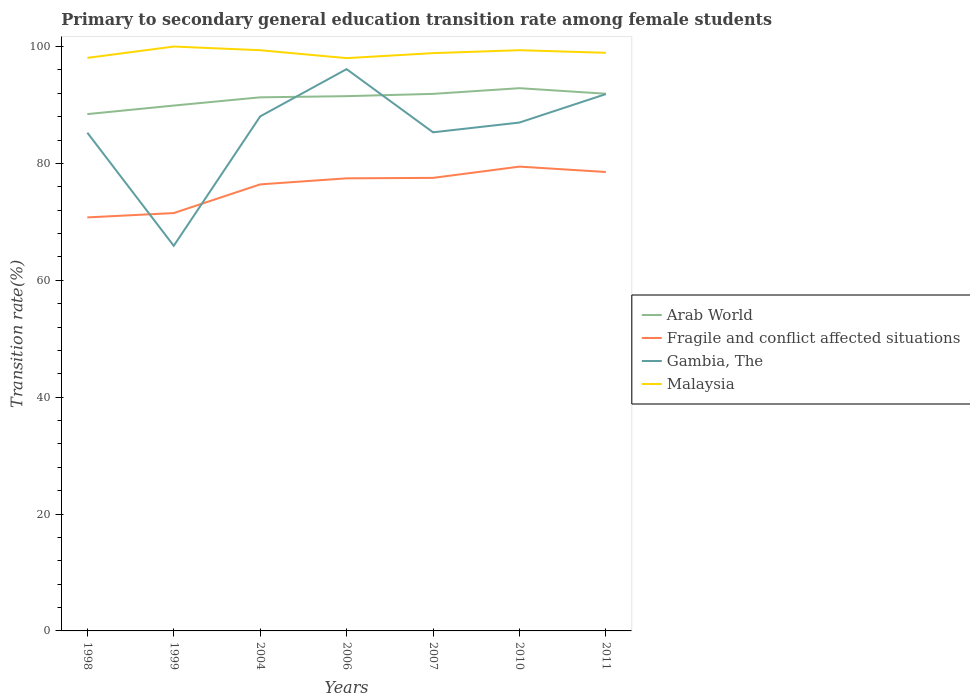How many different coloured lines are there?
Offer a very short reply. 4. Does the line corresponding to Fragile and conflict affected situations intersect with the line corresponding to Malaysia?
Your answer should be compact. No. Is the number of lines equal to the number of legend labels?
Ensure brevity in your answer.  Yes. Across all years, what is the maximum transition rate in Fragile and conflict affected situations?
Offer a terse response. 70.76. In which year was the transition rate in Malaysia maximum?
Make the answer very short. 2006. What is the total transition rate in Arab World in the graph?
Your answer should be compact. -3.07. What is the difference between the highest and the second highest transition rate in Gambia, The?
Keep it short and to the point. 30.23. Is the transition rate in Arab World strictly greater than the transition rate in Malaysia over the years?
Your answer should be very brief. Yes. How many years are there in the graph?
Ensure brevity in your answer.  7. What is the difference between two consecutive major ticks on the Y-axis?
Keep it short and to the point. 20. Are the values on the major ticks of Y-axis written in scientific E-notation?
Your response must be concise. No. Does the graph contain any zero values?
Provide a short and direct response. No. Where does the legend appear in the graph?
Keep it short and to the point. Center right. How are the legend labels stacked?
Keep it short and to the point. Vertical. What is the title of the graph?
Provide a short and direct response. Primary to secondary general education transition rate among female students. What is the label or title of the X-axis?
Offer a terse response. Years. What is the label or title of the Y-axis?
Provide a short and direct response. Transition rate(%). What is the Transition rate(%) in Arab World in 1998?
Ensure brevity in your answer.  88.44. What is the Transition rate(%) of Fragile and conflict affected situations in 1998?
Your answer should be very brief. 70.76. What is the Transition rate(%) of Gambia, The in 1998?
Your answer should be very brief. 85.26. What is the Transition rate(%) in Malaysia in 1998?
Your answer should be compact. 98.06. What is the Transition rate(%) in Arab World in 1999?
Your answer should be compact. 89.9. What is the Transition rate(%) of Fragile and conflict affected situations in 1999?
Offer a very short reply. 71.5. What is the Transition rate(%) of Gambia, The in 1999?
Provide a succinct answer. 65.9. What is the Transition rate(%) of Malaysia in 1999?
Ensure brevity in your answer.  100. What is the Transition rate(%) of Arab World in 2004?
Keep it short and to the point. 91.31. What is the Transition rate(%) of Fragile and conflict affected situations in 2004?
Keep it short and to the point. 76.41. What is the Transition rate(%) of Gambia, The in 2004?
Your response must be concise. 88.05. What is the Transition rate(%) of Malaysia in 2004?
Your response must be concise. 99.37. What is the Transition rate(%) in Arab World in 2006?
Your answer should be compact. 91.51. What is the Transition rate(%) in Fragile and conflict affected situations in 2006?
Your response must be concise. 77.45. What is the Transition rate(%) of Gambia, The in 2006?
Give a very brief answer. 96.13. What is the Transition rate(%) in Malaysia in 2006?
Keep it short and to the point. 98.02. What is the Transition rate(%) of Arab World in 2007?
Offer a terse response. 91.9. What is the Transition rate(%) in Fragile and conflict affected situations in 2007?
Keep it short and to the point. 77.52. What is the Transition rate(%) in Gambia, The in 2007?
Give a very brief answer. 85.32. What is the Transition rate(%) of Malaysia in 2007?
Your response must be concise. 98.87. What is the Transition rate(%) of Arab World in 2010?
Provide a short and direct response. 92.87. What is the Transition rate(%) in Fragile and conflict affected situations in 2010?
Provide a short and direct response. 79.45. What is the Transition rate(%) in Gambia, The in 2010?
Make the answer very short. 86.99. What is the Transition rate(%) of Malaysia in 2010?
Ensure brevity in your answer.  99.37. What is the Transition rate(%) of Arab World in 2011?
Ensure brevity in your answer.  91.92. What is the Transition rate(%) in Fragile and conflict affected situations in 2011?
Your answer should be very brief. 78.53. What is the Transition rate(%) in Gambia, The in 2011?
Your response must be concise. 91.86. What is the Transition rate(%) of Malaysia in 2011?
Provide a short and direct response. 98.93. Across all years, what is the maximum Transition rate(%) in Arab World?
Ensure brevity in your answer.  92.87. Across all years, what is the maximum Transition rate(%) of Fragile and conflict affected situations?
Provide a succinct answer. 79.45. Across all years, what is the maximum Transition rate(%) in Gambia, The?
Give a very brief answer. 96.13. Across all years, what is the minimum Transition rate(%) of Arab World?
Your answer should be compact. 88.44. Across all years, what is the minimum Transition rate(%) of Fragile and conflict affected situations?
Your answer should be very brief. 70.76. Across all years, what is the minimum Transition rate(%) of Gambia, The?
Keep it short and to the point. 65.9. Across all years, what is the minimum Transition rate(%) of Malaysia?
Your answer should be compact. 98.02. What is the total Transition rate(%) in Arab World in the graph?
Make the answer very short. 637.85. What is the total Transition rate(%) in Fragile and conflict affected situations in the graph?
Give a very brief answer. 531.63. What is the total Transition rate(%) of Gambia, The in the graph?
Keep it short and to the point. 599.52. What is the total Transition rate(%) of Malaysia in the graph?
Offer a very short reply. 692.62. What is the difference between the Transition rate(%) in Arab World in 1998 and that in 1999?
Provide a short and direct response. -1.46. What is the difference between the Transition rate(%) in Fragile and conflict affected situations in 1998 and that in 1999?
Make the answer very short. -0.74. What is the difference between the Transition rate(%) of Gambia, The in 1998 and that in 1999?
Provide a succinct answer. 19.36. What is the difference between the Transition rate(%) in Malaysia in 1998 and that in 1999?
Make the answer very short. -1.94. What is the difference between the Transition rate(%) of Arab World in 1998 and that in 2004?
Make the answer very short. -2.87. What is the difference between the Transition rate(%) in Fragile and conflict affected situations in 1998 and that in 2004?
Provide a succinct answer. -5.65. What is the difference between the Transition rate(%) of Gambia, The in 1998 and that in 2004?
Ensure brevity in your answer.  -2.79. What is the difference between the Transition rate(%) in Malaysia in 1998 and that in 2004?
Give a very brief answer. -1.31. What is the difference between the Transition rate(%) in Arab World in 1998 and that in 2006?
Your response must be concise. -3.07. What is the difference between the Transition rate(%) in Fragile and conflict affected situations in 1998 and that in 2006?
Make the answer very short. -6.69. What is the difference between the Transition rate(%) of Gambia, The in 1998 and that in 2006?
Offer a terse response. -10.87. What is the difference between the Transition rate(%) of Malaysia in 1998 and that in 2006?
Your answer should be very brief. 0.04. What is the difference between the Transition rate(%) in Arab World in 1998 and that in 2007?
Give a very brief answer. -3.46. What is the difference between the Transition rate(%) in Fragile and conflict affected situations in 1998 and that in 2007?
Provide a short and direct response. -6.76. What is the difference between the Transition rate(%) in Gambia, The in 1998 and that in 2007?
Provide a short and direct response. -0.06. What is the difference between the Transition rate(%) of Malaysia in 1998 and that in 2007?
Make the answer very short. -0.81. What is the difference between the Transition rate(%) in Arab World in 1998 and that in 2010?
Your answer should be very brief. -4.44. What is the difference between the Transition rate(%) of Fragile and conflict affected situations in 1998 and that in 2010?
Provide a succinct answer. -8.69. What is the difference between the Transition rate(%) of Gambia, The in 1998 and that in 2010?
Provide a succinct answer. -1.73. What is the difference between the Transition rate(%) in Malaysia in 1998 and that in 2010?
Keep it short and to the point. -1.32. What is the difference between the Transition rate(%) of Arab World in 1998 and that in 2011?
Your response must be concise. -3.49. What is the difference between the Transition rate(%) of Fragile and conflict affected situations in 1998 and that in 2011?
Make the answer very short. -7.77. What is the difference between the Transition rate(%) of Gambia, The in 1998 and that in 2011?
Your response must be concise. -6.6. What is the difference between the Transition rate(%) in Malaysia in 1998 and that in 2011?
Your answer should be very brief. -0.87. What is the difference between the Transition rate(%) of Arab World in 1999 and that in 2004?
Offer a very short reply. -1.41. What is the difference between the Transition rate(%) in Fragile and conflict affected situations in 1999 and that in 2004?
Your answer should be very brief. -4.91. What is the difference between the Transition rate(%) in Gambia, The in 1999 and that in 2004?
Provide a succinct answer. -22.15. What is the difference between the Transition rate(%) of Malaysia in 1999 and that in 2004?
Give a very brief answer. 0.63. What is the difference between the Transition rate(%) of Arab World in 1999 and that in 2006?
Give a very brief answer. -1.61. What is the difference between the Transition rate(%) in Fragile and conflict affected situations in 1999 and that in 2006?
Your response must be concise. -5.95. What is the difference between the Transition rate(%) of Gambia, The in 1999 and that in 2006?
Your answer should be compact. -30.23. What is the difference between the Transition rate(%) in Malaysia in 1999 and that in 2006?
Your answer should be very brief. 1.98. What is the difference between the Transition rate(%) in Arab World in 1999 and that in 2007?
Provide a short and direct response. -2. What is the difference between the Transition rate(%) of Fragile and conflict affected situations in 1999 and that in 2007?
Offer a terse response. -6.02. What is the difference between the Transition rate(%) of Gambia, The in 1999 and that in 2007?
Make the answer very short. -19.42. What is the difference between the Transition rate(%) in Malaysia in 1999 and that in 2007?
Make the answer very short. 1.13. What is the difference between the Transition rate(%) of Arab World in 1999 and that in 2010?
Offer a very short reply. -2.97. What is the difference between the Transition rate(%) of Fragile and conflict affected situations in 1999 and that in 2010?
Offer a terse response. -7.95. What is the difference between the Transition rate(%) in Gambia, The in 1999 and that in 2010?
Offer a terse response. -21.09. What is the difference between the Transition rate(%) in Malaysia in 1999 and that in 2010?
Offer a terse response. 0.63. What is the difference between the Transition rate(%) in Arab World in 1999 and that in 2011?
Provide a succinct answer. -2.02. What is the difference between the Transition rate(%) of Fragile and conflict affected situations in 1999 and that in 2011?
Offer a terse response. -7.03. What is the difference between the Transition rate(%) of Gambia, The in 1999 and that in 2011?
Your answer should be compact. -25.96. What is the difference between the Transition rate(%) of Malaysia in 1999 and that in 2011?
Give a very brief answer. 1.07. What is the difference between the Transition rate(%) of Arab World in 2004 and that in 2006?
Your response must be concise. -0.2. What is the difference between the Transition rate(%) in Fragile and conflict affected situations in 2004 and that in 2006?
Keep it short and to the point. -1.04. What is the difference between the Transition rate(%) of Gambia, The in 2004 and that in 2006?
Your response must be concise. -8.09. What is the difference between the Transition rate(%) in Malaysia in 2004 and that in 2006?
Your response must be concise. 1.35. What is the difference between the Transition rate(%) in Arab World in 2004 and that in 2007?
Keep it short and to the point. -0.59. What is the difference between the Transition rate(%) in Fragile and conflict affected situations in 2004 and that in 2007?
Your response must be concise. -1.11. What is the difference between the Transition rate(%) in Gambia, The in 2004 and that in 2007?
Your answer should be compact. 2.72. What is the difference between the Transition rate(%) of Malaysia in 2004 and that in 2007?
Make the answer very short. 0.5. What is the difference between the Transition rate(%) of Arab World in 2004 and that in 2010?
Offer a terse response. -1.56. What is the difference between the Transition rate(%) of Fragile and conflict affected situations in 2004 and that in 2010?
Provide a succinct answer. -3.04. What is the difference between the Transition rate(%) of Gambia, The in 2004 and that in 2010?
Your answer should be very brief. 1.05. What is the difference between the Transition rate(%) of Malaysia in 2004 and that in 2010?
Provide a succinct answer. -0. What is the difference between the Transition rate(%) of Arab World in 2004 and that in 2011?
Ensure brevity in your answer.  -0.61. What is the difference between the Transition rate(%) of Fragile and conflict affected situations in 2004 and that in 2011?
Keep it short and to the point. -2.12. What is the difference between the Transition rate(%) of Gambia, The in 2004 and that in 2011?
Offer a terse response. -3.82. What is the difference between the Transition rate(%) of Malaysia in 2004 and that in 2011?
Provide a short and direct response. 0.44. What is the difference between the Transition rate(%) of Arab World in 2006 and that in 2007?
Offer a very short reply. -0.39. What is the difference between the Transition rate(%) of Fragile and conflict affected situations in 2006 and that in 2007?
Ensure brevity in your answer.  -0.08. What is the difference between the Transition rate(%) of Gambia, The in 2006 and that in 2007?
Give a very brief answer. 10.81. What is the difference between the Transition rate(%) in Malaysia in 2006 and that in 2007?
Provide a short and direct response. -0.86. What is the difference between the Transition rate(%) in Arab World in 2006 and that in 2010?
Provide a short and direct response. -1.36. What is the difference between the Transition rate(%) in Fragile and conflict affected situations in 2006 and that in 2010?
Provide a succinct answer. -2. What is the difference between the Transition rate(%) in Gambia, The in 2006 and that in 2010?
Your answer should be very brief. 9.14. What is the difference between the Transition rate(%) in Malaysia in 2006 and that in 2010?
Keep it short and to the point. -1.36. What is the difference between the Transition rate(%) of Arab World in 2006 and that in 2011?
Your answer should be very brief. -0.41. What is the difference between the Transition rate(%) in Fragile and conflict affected situations in 2006 and that in 2011?
Offer a terse response. -1.08. What is the difference between the Transition rate(%) in Gambia, The in 2006 and that in 2011?
Offer a very short reply. 4.27. What is the difference between the Transition rate(%) in Malaysia in 2006 and that in 2011?
Provide a succinct answer. -0.91. What is the difference between the Transition rate(%) of Arab World in 2007 and that in 2010?
Your answer should be compact. -0.97. What is the difference between the Transition rate(%) of Fragile and conflict affected situations in 2007 and that in 2010?
Provide a succinct answer. -1.93. What is the difference between the Transition rate(%) of Gambia, The in 2007 and that in 2010?
Ensure brevity in your answer.  -1.67. What is the difference between the Transition rate(%) in Malaysia in 2007 and that in 2010?
Keep it short and to the point. -0.5. What is the difference between the Transition rate(%) in Arab World in 2007 and that in 2011?
Provide a succinct answer. -0.02. What is the difference between the Transition rate(%) of Fragile and conflict affected situations in 2007 and that in 2011?
Give a very brief answer. -1.01. What is the difference between the Transition rate(%) in Gambia, The in 2007 and that in 2011?
Ensure brevity in your answer.  -6.54. What is the difference between the Transition rate(%) of Malaysia in 2007 and that in 2011?
Make the answer very short. -0.06. What is the difference between the Transition rate(%) in Arab World in 2010 and that in 2011?
Ensure brevity in your answer.  0.95. What is the difference between the Transition rate(%) of Fragile and conflict affected situations in 2010 and that in 2011?
Your response must be concise. 0.92. What is the difference between the Transition rate(%) of Gambia, The in 2010 and that in 2011?
Provide a short and direct response. -4.87. What is the difference between the Transition rate(%) in Malaysia in 2010 and that in 2011?
Offer a terse response. 0.45. What is the difference between the Transition rate(%) of Arab World in 1998 and the Transition rate(%) of Fragile and conflict affected situations in 1999?
Offer a terse response. 16.94. What is the difference between the Transition rate(%) in Arab World in 1998 and the Transition rate(%) in Gambia, The in 1999?
Offer a terse response. 22.54. What is the difference between the Transition rate(%) in Arab World in 1998 and the Transition rate(%) in Malaysia in 1999?
Provide a succinct answer. -11.56. What is the difference between the Transition rate(%) in Fragile and conflict affected situations in 1998 and the Transition rate(%) in Gambia, The in 1999?
Your response must be concise. 4.86. What is the difference between the Transition rate(%) in Fragile and conflict affected situations in 1998 and the Transition rate(%) in Malaysia in 1999?
Make the answer very short. -29.24. What is the difference between the Transition rate(%) in Gambia, The in 1998 and the Transition rate(%) in Malaysia in 1999?
Make the answer very short. -14.74. What is the difference between the Transition rate(%) in Arab World in 1998 and the Transition rate(%) in Fragile and conflict affected situations in 2004?
Provide a succinct answer. 12.02. What is the difference between the Transition rate(%) in Arab World in 1998 and the Transition rate(%) in Gambia, The in 2004?
Your response must be concise. 0.39. What is the difference between the Transition rate(%) of Arab World in 1998 and the Transition rate(%) of Malaysia in 2004?
Provide a succinct answer. -10.93. What is the difference between the Transition rate(%) in Fragile and conflict affected situations in 1998 and the Transition rate(%) in Gambia, The in 2004?
Your response must be concise. -17.29. What is the difference between the Transition rate(%) of Fragile and conflict affected situations in 1998 and the Transition rate(%) of Malaysia in 2004?
Give a very brief answer. -28.61. What is the difference between the Transition rate(%) in Gambia, The in 1998 and the Transition rate(%) in Malaysia in 2004?
Your response must be concise. -14.11. What is the difference between the Transition rate(%) in Arab World in 1998 and the Transition rate(%) in Fragile and conflict affected situations in 2006?
Your answer should be very brief. 10.99. What is the difference between the Transition rate(%) in Arab World in 1998 and the Transition rate(%) in Gambia, The in 2006?
Your answer should be compact. -7.7. What is the difference between the Transition rate(%) of Arab World in 1998 and the Transition rate(%) of Malaysia in 2006?
Make the answer very short. -9.58. What is the difference between the Transition rate(%) in Fragile and conflict affected situations in 1998 and the Transition rate(%) in Gambia, The in 2006?
Your response must be concise. -25.37. What is the difference between the Transition rate(%) of Fragile and conflict affected situations in 1998 and the Transition rate(%) of Malaysia in 2006?
Your response must be concise. -27.25. What is the difference between the Transition rate(%) of Gambia, The in 1998 and the Transition rate(%) of Malaysia in 2006?
Make the answer very short. -12.75. What is the difference between the Transition rate(%) in Arab World in 1998 and the Transition rate(%) in Fragile and conflict affected situations in 2007?
Provide a succinct answer. 10.91. What is the difference between the Transition rate(%) in Arab World in 1998 and the Transition rate(%) in Gambia, The in 2007?
Provide a succinct answer. 3.11. What is the difference between the Transition rate(%) of Arab World in 1998 and the Transition rate(%) of Malaysia in 2007?
Offer a very short reply. -10.44. What is the difference between the Transition rate(%) in Fragile and conflict affected situations in 1998 and the Transition rate(%) in Gambia, The in 2007?
Offer a very short reply. -14.56. What is the difference between the Transition rate(%) in Fragile and conflict affected situations in 1998 and the Transition rate(%) in Malaysia in 2007?
Give a very brief answer. -28.11. What is the difference between the Transition rate(%) in Gambia, The in 1998 and the Transition rate(%) in Malaysia in 2007?
Your answer should be very brief. -13.61. What is the difference between the Transition rate(%) in Arab World in 1998 and the Transition rate(%) in Fragile and conflict affected situations in 2010?
Provide a succinct answer. 8.98. What is the difference between the Transition rate(%) of Arab World in 1998 and the Transition rate(%) of Gambia, The in 2010?
Provide a succinct answer. 1.44. What is the difference between the Transition rate(%) in Arab World in 1998 and the Transition rate(%) in Malaysia in 2010?
Offer a very short reply. -10.94. What is the difference between the Transition rate(%) of Fragile and conflict affected situations in 1998 and the Transition rate(%) of Gambia, The in 2010?
Offer a very short reply. -16.23. What is the difference between the Transition rate(%) in Fragile and conflict affected situations in 1998 and the Transition rate(%) in Malaysia in 2010?
Keep it short and to the point. -28.61. What is the difference between the Transition rate(%) in Gambia, The in 1998 and the Transition rate(%) in Malaysia in 2010?
Ensure brevity in your answer.  -14.11. What is the difference between the Transition rate(%) in Arab World in 1998 and the Transition rate(%) in Fragile and conflict affected situations in 2011?
Your response must be concise. 9.91. What is the difference between the Transition rate(%) of Arab World in 1998 and the Transition rate(%) of Gambia, The in 2011?
Make the answer very short. -3.43. What is the difference between the Transition rate(%) in Arab World in 1998 and the Transition rate(%) in Malaysia in 2011?
Your response must be concise. -10.49. What is the difference between the Transition rate(%) in Fragile and conflict affected situations in 1998 and the Transition rate(%) in Gambia, The in 2011?
Keep it short and to the point. -21.1. What is the difference between the Transition rate(%) in Fragile and conflict affected situations in 1998 and the Transition rate(%) in Malaysia in 2011?
Provide a short and direct response. -28.17. What is the difference between the Transition rate(%) in Gambia, The in 1998 and the Transition rate(%) in Malaysia in 2011?
Make the answer very short. -13.67. What is the difference between the Transition rate(%) in Arab World in 1999 and the Transition rate(%) in Fragile and conflict affected situations in 2004?
Give a very brief answer. 13.49. What is the difference between the Transition rate(%) of Arab World in 1999 and the Transition rate(%) of Gambia, The in 2004?
Offer a terse response. 1.85. What is the difference between the Transition rate(%) of Arab World in 1999 and the Transition rate(%) of Malaysia in 2004?
Your answer should be compact. -9.47. What is the difference between the Transition rate(%) in Fragile and conflict affected situations in 1999 and the Transition rate(%) in Gambia, The in 2004?
Offer a terse response. -16.55. What is the difference between the Transition rate(%) of Fragile and conflict affected situations in 1999 and the Transition rate(%) of Malaysia in 2004?
Your answer should be compact. -27.87. What is the difference between the Transition rate(%) in Gambia, The in 1999 and the Transition rate(%) in Malaysia in 2004?
Make the answer very short. -33.47. What is the difference between the Transition rate(%) of Arab World in 1999 and the Transition rate(%) of Fragile and conflict affected situations in 2006?
Your response must be concise. 12.45. What is the difference between the Transition rate(%) in Arab World in 1999 and the Transition rate(%) in Gambia, The in 2006?
Give a very brief answer. -6.23. What is the difference between the Transition rate(%) of Arab World in 1999 and the Transition rate(%) of Malaysia in 2006?
Make the answer very short. -8.12. What is the difference between the Transition rate(%) of Fragile and conflict affected situations in 1999 and the Transition rate(%) of Gambia, The in 2006?
Give a very brief answer. -24.63. What is the difference between the Transition rate(%) of Fragile and conflict affected situations in 1999 and the Transition rate(%) of Malaysia in 2006?
Make the answer very short. -26.51. What is the difference between the Transition rate(%) in Gambia, The in 1999 and the Transition rate(%) in Malaysia in 2006?
Give a very brief answer. -32.11. What is the difference between the Transition rate(%) of Arab World in 1999 and the Transition rate(%) of Fragile and conflict affected situations in 2007?
Make the answer very short. 12.38. What is the difference between the Transition rate(%) in Arab World in 1999 and the Transition rate(%) in Gambia, The in 2007?
Give a very brief answer. 4.58. What is the difference between the Transition rate(%) of Arab World in 1999 and the Transition rate(%) of Malaysia in 2007?
Make the answer very short. -8.97. What is the difference between the Transition rate(%) in Fragile and conflict affected situations in 1999 and the Transition rate(%) in Gambia, The in 2007?
Give a very brief answer. -13.82. What is the difference between the Transition rate(%) in Fragile and conflict affected situations in 1999 and the Transition rate(%) in Malaysia in 2007?
Provide a short and direct response. -27.37. What is the difference between the Transition rate(%) in Gambia, The in 1999 and the Transition rate(%) in Malaysia in 2007?
Make the answer very short. -32.97. What is the difference between the Transition rate(%) of Arab World in 1999 and the Transition rate(%) of Fragile and conflict affected situations in 2010?
Make the answer very short. 10.45. What is the difference between the Transition rate(%) of Arab World in 1999 and the Transition rate(%) of Gambia, The in 2010?
Provide a short and direct response. 2.91. What is the difference between the Transition rate(%) of Arab World in 1999 and the Transition rate(%) of Malaysia in 2010?
Give a very brief answer. -9.47. What is the difference between the Transition rate(%) of Fragile and conflict affected situations in 1999 and the Transition rate(%) of Gambia, The in 2010?
Give a very brief answer. -15.49. What is the difference between the Transition rate(%) of Fragile and conflict affected situations in 1999 and the Transition rate(%) of Malaysia in 2010?
Provide a succinct answer. -27.87. What is the difference between the Transition rate(%) of Gambia, The in 1999 and the Transition rate(%) of Malaysia in 2010?
Your answer should be very brief. -33.47. What is the difference between the Transition rate(%) of Arab World in 1999 and the Transition rate(%) of Fragile and conflict affected situations in 2011?
Provide a succinct answer. 11.37. What is the difference between the Transition rate(%) of Arab World in 1999 and the Transition rate(%) of Gambia, The in 2011?
Your answer should be very brief. -1.96. What is the difference between the Transition rate(%) of Arab World in 1999 and the Transition rate(%) of Malaysia in 2011?
Offer a very short reply. -9.03. What is the difference between the Transition rate(%) in Fragile and conflict affected situations in 1999 and the Transition rate(%) in Gambia, The in 2011?
Your response must be concise. -20.36. What is the difference between the Transition rate(%) in Fragile and conflict affected situations in 1999 and the Transition rate(%) in Malaysia in 2011?
Your answer should be very brief. -27.43. What is the difference between the Transition rate(%) in Gambia, The in 1999 and the Transition rate(%) in Malaysia in 2011?
Keep it short and to the point. -33.03. What is the difference between the Transition rate(%) in Arab World in 2004 and the Transition rate(%) in Fragile and conflict affected situations in 2006?
Give a very brief answer. 13.86. What is the difference between the Transition rate(%) of Arab World in 2004 and the Transition rate(%) of Gambia, The in 2006?
Make the answer very short. -4.82. What is the difference between the Transition rate(%) of Arab World in 2004 and the Transition rate(%) of Malaysia in 2006?
Offer a very short reply. -6.71. What is the difference between the Transition rate(%) of Fragile and conflict affected situations in 2004 and the Transition rate(%) of Gambia, The in 2006?
Provide a succinct answer. -19.72. What is the difference between the Transition rate(%) in Fragile and conflict affected situations in 2004 and the Transition rate(%) in Malaysia in 2006?
Your answer should be very brief. -21.6. What is the difference between the Transition rate(%) in Gambia, The in 2004 and the Transition rate(%) in Malaysia in 2006?
Provide a short and direct response. -9.97. What is the difference between the Transition rate(%) in Arab World in 2004 and the Transition rate(%) in Fragile and conflict affected situations in 2007?
Keep it short and to the point. 13.79. What is the difference between the Transition rate(%) of Arab World in 2004 and the Transition rate(%) of Gambia, The in 2007?
Provide a short and direct response. 5.99. What is the difference between the Transition rate(%) of Arab World in 2004 and the Transition rate(%) of Malaysia in 2007?
Your answer should be compact. -7.56. What is the difference between the Transition rate(%) in Fragile and conflict affected situations in 2004 and the Transition rate(%) in Gambia, The in 2007?
Make the answer very short. -8.91. What is the difference between the Transition rate(%) of Fragile and conflict affected situations in 2004 and the Transition rate(%) of Malaysia in 2007?
Keep it short and to the point. -22.46. What is the difference between the Transition rate(%) in Gambia, The in 2004 and the Transition rate(%) in Malaysia in 2007?
Provide a succinct answer. -10.83. What is the difference between the Transition rate(%) in Arab World in 2004 and the Transition rate(%) in Fragile and conflict affected situations in 2010?
Your response must be concise. 11.86. What is the difference between the Transition rate(%) of Arab World in 2004 and the Transition rate(%) of Gambia, The in 2010?
Offer a very short reply. 4.32. What is the difference between the Transition rate(%) in Arab World in 2004 and the Transition rate(%) in Malaysia in 2010?
Offer a terse response. -8.06. What is the difference between the Transition rate(%) of Fragile and conflict affected situations in 2004 and the Transition rate(%) of Gambia, The in 2010?
Provide a succinct answer. -10.58. What is the difference between the Transition rate(%) in Fragile and conflict affected situations in 2004 and the Transition rate(%) in Malaysia in 2010?
Offer a very short reply. -22.96. What is the difference between the Transition rate(%) of Gambia, The in 2004 and the Transition rate(%) of Malaysia in 2010?
Keep it short and to the point. -11.33. What is the difference between the Transition rate(%) in Arab World in 2004 and the Transition rate(%) in Fragile and conflict affected situations in 2011?
Your answer should be very brief. 12.78. What is the difference between the Transition rate(%) of Arab World in 2004 and the Transition rate(%) of Gambia, The in 2011?
Ensure brevity in your answer.  -0.55. What is the difference between the Transition rate(%) of Arab World in 2004 and the Transition rate(%) of Malaysia in 2011?
Your answer should be very brief. -7.62. What is the difference between the Transition rate(%) in Fragile and conflict affected situations in 2004 and the Transition rate(%) in Gambia, The in 2011?
Your answer should be very brief. -15.45. What is the difference between the Transition rate(%) in Fragile and conflict affected situations in 2004 and the Transition rate(%) in Malaysia in 2011?
Offer a very short reply. -22.52. What is the difference between the Transition rate(%) of Gambia, The in 2004 and the Transition rate(%) of Malaysia in 2011?
Offer a terse response. -10.88. What is the difference between the Transition rate(%) of Arab World in 2006 and the Transition rate(%) of Fragile and conflict affected situations in 2007?
Your answer should be compact. 13.99. What is the difference between the Transition rate(%) of Arab World in 2006 and the Transition rate(%) of Gambia, The in 2007?
Your response must be concise. 6.19. What is the difference between the Transition rate(%) of Arab World in 2006 and the Transition rate(%) of Malaysia in 2007?
Give a very brief answer. -7.36. What is the difference between the Transition rate(%) in Fragile and conflict affected situations in 2006 and the Transition rate(%) in Gambia, The in 2007?
Offer a terse response. -7.87. What is the difference between the Transition rate(%) in Fragile and conflict affected situations in 2006 and the Transition rate(%) in Malaysia in 2007?
Give a very brief answer. -21.42. What is the difference between the Transition rate(%) of Gambia, The in 2006 and the Transition rate(%) of Malaysia in 2007?
Make the answer very short. -2.74. What is the difference between the Transition rate(%) in Arab World in 2006 and the Transition rate(%) in Fragile and conflict affected situations in 2010?
Your answer should be compact. 12.06. What is the difference between the Transition rate(%) of Arab World in 2006 and the Transition rate(%) of Gambia, The in 2010?
Keep it short and to the point. 4.52. What is the difference between the Transition rate(%) of Arab World in 2006 and the Transition rate(%) of Malaysia in 2010?
Provide a succinct answer. -7.86. What is the difference between the Transition rate(%) in Fragile and conflict affected situations in 2006 and the Transition rate(%) in Gambia, The in 2010?
Provide a short and direct response. -9.54. What is the difference between the Transition rate(%) of Fragile and conflict affected situations in 2006 and the Transition rate(%) of Malaysia in 2010?
Give a very brief answer. -21.93. What is the difference between the Transition rate(%) of Gambia, The in 2006 and the Transition rate(%) of Malaysia in 2010?
Your response must be concise. -3.24. What is the difference between the Transition rate(%) of Arab World in 2006 and the Transition rate(%) of Fragile and conflict affected situations in 2011?
Your answer should be very brief. 12.98. What is the difference between the Transition rate(%) in Arab World in 2006 and the Transition rate(%) in Gambia, The in 2011?
Your answer should be very brief. -0.35. What is the difference between the Transition rate(%) in Arab World in 2006 and the Transition rate(%) in Malaysia in 2011?
Provide a succinct answer. -7.42. What is the difference between the Transition rate(%) in Fragile and conflict affected situations in 2006 and the Transition rate(%) in Gambia, The in 2011?
Make the answer very short. -14.42. What is the difference between the Transition rate(%) in Fragile and conflict affected situations in 2006 and the Transition rate(%) in Malaysia in 2011?
Provide a succinct answer. -21.48. What is the difference between the Transition rate(%) of Gambia, The in 2006 and the Transition rate(%) of Malaysia in 2011?
Provide a succinct answer. -2.79. What is the difference between the Transition rate(%) in Arab World in 2007 and the Transition rate(%) in Fragile and conflict affected situations in 2010?
Provide a short and direct response. 12.45. What is the difference between the Transition rate(%) of Arab World in 2007 and the Transition rate(%) of Gambia, The in 2010?
Provide a succinct answer. 4.91. What is the difference between the Transition rate(%) of Arab World in 2007 and the Transition rate(%) of Malaysia in 2010?
Give a very brief answer. -7.47. What is the difference between the Transition rate(%) of Fragile and conflict affected situations in 2007 and the Transition rate(%) of Gambia, The in 2010?
Keep it short and to the point. -9.47. What is the difference between the Transition rate(%) of Fragile and conflict affected situations in 2007 and the Transition rate(%) of Malaysia in 2010?
Make the answer very short. -21.85. What is the difference between the Transition rate(%) in Gambia, The in 2007 and the Transition rate(%) in Malaysia in 2010?
Ensure brevity in your answer.  -14.05. What is the difference between the Transition rate(%) in Arab World in 2007 and the Transition rate(%) in Fragile and conflict affected situations in 2011?
Your response must be concise. 13.37. What is the difference between the Transition rate(%) in Arab World in 2007 and the Transition rate(%) in Gambia, The in 2011?
Provide a short and direct response. 0.04. What is the difference between the Transition rate(%) of Arab World in 2007 and the Transition rate(%) of Malaysia in 2011?
Your response must be concise. -7.03. What is the difference between the Transition rate(%) of Fragile and conflict affected situations in 2007 and the Transition rate(%) of Gambia, The in 2011?
Offer a very short reply. -14.34. What is the difference between the Transition rate(%) of Fragile and conflict affected situations in 2007 and the Transition rate(%) of Malaysia in 2011?
Provide a succinct answer. -21.4. What is the difference between the Transition rate(%) of Gambia, The in 2007 and the Transition rate(%) of Malaysia in 2011?
Your answer should be very brief. -13.6. What is the difference between the Transition rate(%) of Arab World in 2010 and the Transition rate(%) of Fragile and conflict affected situations in 2011?
Offer a very short reply. 14.34. What is the difference between the Transition rate(%) of Arab World in 2010 and the Transition rate(%) of Gambia, The in 2011?
Offer a very short reply. 1.01. What is the difference between the Transition rate(%) of Arab World in 2010 and the Transition rate(%) of Malaysia in 2011?
Your response must be concise. -6.05. What is the difference between the Transition rate(%) in Fragile and conflict affected situations in 2010 and the Transition rate(%) in Gambia, The in 2011?
Make the answer very short. -12.41. What is the difference between the Transition rate(%) of Fragile and conflict affected situations in 2010 and the Transition rate(%) of Malaysia in 2011?
Provide a succinct answer. -19.47. What is the difference between the Transition rate(%) of Gambia, The in 2010 and the Transition rate(%) of Malaysia in 2011?
Provide a short and direct response. -11.93. What is the average Transition rate(%) of Arab World per year?
Provide a short and direct response. 91.12. What is the average Transition rate(%) of Fragile and conflict affected situations per year?
Ensure brevity in your answer.  75.95. What is the average Transition rate(%) in Gambia, The per year?
Give a very brief answer. 85.65. What is the average Transition rate(%) of Malaysia per year?
Provide a short and direct response. 98.95. In the year 1998, what is the difference between the Transition rate(%) of Arab World and Transition rate(%) of Fragile and conflict affected situations?
Ensure brevity in your answer.  17.68. In the year 1998, what is the difference between the Transition rate(%) in Arab World and Transition rate(%) in Gambia, The?
Offer a terse response. 3.18. In the year 1998, what is the difference between the Transition rate(%) of Arab World and Transition rate(%) of Malaysia?
Your answer should be very brief. -9.62. In the year 1998, what is the difference between the Transition rate(%) in Fragile and conflict affected situations and Transition rate(%) in Gambia, The?
Offer a very short reply. -14.5. In the year 1998, what is the difference between the Transition rate(%) of Fragile and conflict affected situations and Transition rate(%) of Malaysia?
Keep it short and to the point. -27.3. In the year 1998, what is the difference between the Transition rate(%) of Gambia, The and Transition rate(%) of Malaysia?
Provide a short and direct response. -12.8. In the year 1999, what is the difference between the Transition rate(%) in Arab World and Transition rate(%) in Fragile and conflict affected situations?
Provide a short and direct response. 18.4. In the year 1999, what is the difference between the Transition rate(%) of Arab World and Transition rate(%) of Gambia, The?
Provide a short and direct response. 24. In the year 1999, what is the difference between the Transition rate(%) of Arab World and Transition rate(%) of Malaysia?
Give a very brief answer. -10.1. In the year 1999, what is the difference between the Transition rate(%) of Fragile and conflict affected situations and Transition rate(%) of Gambia, The?
Provide a succinct answer. 5.6. In the year 1999, what is the difference between the Transition rate(%) in Fragile and conflict affected situations and Transition rate(%) in Malaysia?
Offer a very short reply. -28.5. In the year 1999, what is the difference between the Transition rate(%) in Gambia, The and Transition rate(%) in Malaysia?
Your answer should be very brief. -34.1. In the year 2004, what is the difference between the Transition rate(%) in Arab World and Transition rate(%) in Fragile and conflict affected situations?
Your answer should be compact. 14.9. In the year 2004, what is the difference between the Transition rate(%) of Arab World and Transition rate(%) of Gambia, The?
Ensure brevity in your answer.  3.26. In the year 2004, what is the difference between the Transition rate(%) in Arab World and Transition rate(%) in Malaysia?
Your answer should be very brief. -8.06. In the year 2004, what is the difference between the Transition rate(%) in Fragile and conflict affected situations and Transition rate(%) in Gambia, The?
Offer a very short reply. -11.63. In the year 2004, what is the difference between the Transition rate(%) of Fragile and conflict affected situations and Transition rate(%) of Malaysia?
Give a very brief answer. -22.96. In the year 2004, what is the difference between the Transition rate(%) of Gambia, The and Transition rate(%) of Malaysia?
Your answer should be very brief. -11.32. In the year 2006, what is the difference between the Transition rate(%) of Arab World and Transition rate(%) of Fragile and conflict affected situations?
Your response must be concise. 14.06. In the year 2006, what is the difference between the Transition rate(%) in Arab World and Transition rate(%) in Gambia, The?
Provide a succinct answer. -4.62. In the year 2006, what is the difference between the Transition rate(%) in Arab World and Transition rate(%) in Malaysia?
Offer a very short reply. -6.51. In the year 2006, what is the difference between the Transition rate(%) of Fragile and conflict affected situations and Transition rate(%) of Gambia, The?
Make the answer very short. -18.68. In the year 2006, what is the difference between the Transition rate(%) of Fragile and conflict affected situations and Transition rate(%) of Malaysia?
Your response must be concise. -20.57. In the year 2006, what is the difference between the Transition rate(%) in Gambia, The and Transition rate(%) in Malaysia?
Make the answer very short. -1.88. In the year 2007, what is the difference between the Transition rate(%) of Arab World and Transition rate(%) of Fragile and conflict affected situations?
Keep it short and to the point. 14.38. In the year 2007, what is the difference between the Transition rate(%) of Arab World and Transition rate(%) of Gambia, The?
Offer a terse response. 6.58. In the year 2007, what is the difference between the Transition rate(%) of Arab World and Transition rate(%) of Malaysia?
Ensure brevity in your answer.  -6.97. In the year 2007, what is the difference between the Transition rate(%) in Fragile and conflict affected situations and Transition rate(%) in Gambia, The?
Your response must be concise. -7.8. In the year 2007, what is the difference between the Transition rate(%) of Fragile and conflict affected situations and Transition rate(%) of Malaysia?
Provide a short and direct response. -21.35. In the year 2007, what is the difference between the Transition rate(%) of Gambia, The and Transition rate(%) of Malaysia?
Give a very brief answer. -13.55. In the year 2010, what is the difference between the Transition rate(%) in Arab World and Transition rate(%) in Fragile and conflict affected situations?
Your answer should be very brief. 13.42. In the year 2010, what is the difference between the Transition rate(%) in Arab World and Transition rate(%) in Gambia, The?
Your answer should be compact. 5.88. In the year 2010, what is the difference between the Transition rate(%) of Arab World and Transition rate(%) of Malaysia?
Your answer should be compact. -6.5. In the year 2010, what is the difference between the Transition rate(%) of Fragile and conflict affected situations and Transition rate(%) of Gambia, The?
Your answer should be compact. -7.54. In the year 2010, what is the difference between the Transition rate(%) of Fragile and conflict affected situations and Transition rate(%) of Malaysia?
Offer a terse response. -19.92. In the year 2010, what is the difference between the Transition rate(%) of Gambia, The and Transition rate(%) of Malaysia?
Offer a terse response. -12.38. In the year 2011, what is the difference between the Transition rate(%) of Arab World and Transition rate(%) of Fragile and conflict affected situations?
Your response must be concise. 13.39. In the year 2011, what is the difference between the Transition rate(%) of Arab World and Transition rate(%) of Gambia, The?
Make the answer very short. 0.06. In the year 2011, what is the difference between the Transition rate(%) in Arab World and Transition rate(%) in Malaysia?
Provide a succinct answer. -7.01. In the year 2011, what is the difference between the Transition rate(%) of Fragile and conflict affected situations and Transition rate(%) of Gambia, The?
Offer a very short reply. -13.33. In the year 2011, what is the difference between the Transition rate(%) of Fragile and conflict affected situations and Transition rate(%) of Malaysia?
Your response must be concise. -20.4. In the year 2011, what is the difference between the Transition rate(%) of Gambia, The and Transition rate(%) of Malaysia?
Offer a very short reply. -7.06. What is the ratio of the Transition rate(%) in Arab World in 1998 to that in 1999?
Ensure brevity in your answer.  0.98. What is the ratio of the Transition rate(%) of Gambia, The in 1998 to that in 1999?
Your answer should be very brief. 1.29. What is the ratio of the Transition rate(%) in Malaysia in 1998 to that in 1999?
Ensure brevity in your answer.  0.98. What is the ratio of the Transition rate(%) in Arab World in 1998 to that in 2004?
Give a very brief answer. 0.97. What is the ratio of the Transition rate(%) in Fragile and conflict affected situations in 1998 to that in 2004?
Offer a very short reply. 0.93. What is the ratio of the Transition rate(%) in Gambia, The in 1998 to that in 2004?
Give a very brief answer. 0.97. What is the ratio of the Transition rate(%) of Arab World in 1998 to that in 2006?
Offer a terse response. 0.97. What is the ratio of the Transition rate(%) of Fragile and conflict affected situations in 1998 to that in 2006?
Your answer should be very brief. 0.91. What is the ratio of the Transition rate(%) of Gambia, The in 1998 to that in 2006?
Offer a terse response. 0.89. What is the ratio of the Transition rate(%) of Malaysia in 1998 to that in 2006?
Keep it short and to the point. 1. What is the ratio of the Transition rate(%) of Arab World in 1998 to that in 2007?
Your response must be concise. 0.96. What is the ratio of the Transition rate(%) of Fragile and conflict affected situations in 1998 to that in 2007?
Offer a very short reply. 0.91. What is the ratio of the Transition rate(%) of Arab World in 1998 to that in 2010?
Provide a succinct answer. 0.95. What is the ratio of the Transition rate(%) of Fragile and conflict affected situations in 1998 to that in 2010?
Your answer should be very brief. 0.89. What is the ratio of the Transition rate(%) in Gambia, The in 1998 to that in 2010?
Give a very brief answer. 0.98. What is the ratio of the Transition rate(%) in Malaysia in 1998 to that in 2010?
Provide a short and direct response. 0.99. What is the ratio of the Transition rate(%) in Arab World in 1998 to that in 2011?
Provide a succinct answer. 0.96. What is the ratio of the Transition rate(%) of Fragile and conflict affected situations in 1998 to that in 2011?
Your response must be concise. 0.9. What is the ratio of the Transition rate(%) of Gambia, The in 1998 to that in 2011?
Your answer should be very brief. 0.93. What is the ratio of the Transition rate(%) of Arab World in 1999 to that in 2004?
Offer a very short reply. 0.98. What is the ratio of the Transition rate(%) in Fragile and conflict affected situations in 1999 to that in 2004?
Keep it short and to the point. 0.94. What is the ratio of the Transition rate(%) of Gambia, The in 1999 to that in 2004?
Provide a short and direct response. 0.75. What is the ratio of the Transition rate(%) in Arab World in 1999 to that in 2006?
Offer a terse response. 0.98. What is the ratio of the Transition rate(%) in Fragile and conflict affected situations in 1999 to that in 2006?
Ensure brevity in your answer.  0.92. What is the ratio of the Transition rate(%) in Gambia, The in 1999 to that in 2006?
Ensure brevity in your answer.  0.69. What is the ratio of the Transition rate(%) in Malaysia in 1999 to that in 2006?
Your answer should be very brief. 1.02. What is the ratio of the Transition rate(%) in Arab World in 1999 to that in 2007?
Your response must be concise. 0.98. What is the ratio of the Transition rate(%) in Fragile and conflict affected situations in 1999 to that in 2007?
Your answer should be compact. 0.92. What is the ratio of the Transition rate(%) in Gambia, The in 1999 to that in 2007?
Offer a terse response. 0.77. What is the ratio of the Transition rate(%) in Malaysia in 1999 to that in 2007?
Keep it short and to the point. 1.01. What is the ratio of the Transition rate(%) of Arab World in 1999 to that in 2010?
Your answer should be very brief. 0.97. What is the ratio of the Transition rate(%) of Fragile and conflict affected situations in 1999 to that in 2010?
Offer a terse response. 0.9. What is the ratio of the Transition rate(%) of Gambia, The in 1999 to that in 2010?
Offer a very short reply. 0.76. What is the ratio of the Transition rate(%) in Fragile and conflict affected situations in 1999 to that in 2011?
Keep it short and to the point. 0.91. What is the ratio of the Transition rate(%) in Gambia, The in 1999 to that in 2011?
Provide a succinct answer. 0.72. What is the ratio of the Transition rate(%) in Malaysia in 1999 to that in 2011?
Provide a short and direct response. 1.01. What is the ratio of the Transition rate(%) in Arab World in 2004 to that in 2006?
Give a very brief answer. 1. What is the ratio of the Transition rate(%) in Fragile and conflict affected situations in 2004 to that in 2006?
Provide a short and direct response. 0.99. What is the ratio of the Transition rate(%) of Gambia, The in 2004 to that in 2006?
Your answer should be very brief. 0.92. What is the ratio of the Transition rate(%) in Malaysia in 2004 to that in 2006?
Offer a very short reply. 1.01. What is the ratio of the Transition rate(%) of Fragile and conflict affected situations in 2004 to that in 2007?
Ensure brevity in your answer.  0.99. What is the ratio of the Transition rate(%) of Gambia, The in 2004 to that in 2007?
Offer a terse response. 1.03. What is the ratio of the Transition rate(%) in Arab World in 2004 to that in 2010?
Keep it short and to the point. 0.98. What is the ratio of the Transition rate(%) of Fragile and conflict affected situations in 2004 to that in 2010?
Ensure brevity in your answer.  0.96. What is the ratio of the Transition rate(%) in Gambia, The in 2004 to that in 2010?
Offer a terse response. 1.01. What is the ratio of the Transition rate(%) of Malaysia in 2004 to that in 2010?
Give a very brief answer. 1. What is the ratio of the Transition rate(%) of Gambia, The in 2004 to that in 2011?
Make the answer very short. 0.96. What is the ratio of the Transition rate(%) of Gambia, The in 2006 to that in 2007?
Offer a terse response. 1.13. What is the ratio of the Transition rate(%) of Malaysia in 2006 to that in 2007?
Keep it short and to the point. 0.99. What is the ratio of the Transition rate(%) of Arab World in 2006 to that in 2010?
Keep it short and to the point. 0.99. What is the ratio of the Transition rate(%) of Fragile and conflict affected situations in 2006 to that in 2010?
Your response must be concise. 0.97. What is the ratio of the Transition rate(%) in Gambia, The in 2006 to that in 2010?
Offer a terse response. 1.11. What is the ratio of the Transition rate(%) in Malaysia in 2006 to that in 2010?
Provide a succinct answer. 0.99. What is the ratio of the Transition rate(%) of Arab World in 2006 to that in 2011?
Offer a terse response. 1. What is the ratio of the Transition rate(%) of Fragile and conflict affected situations in 2006 to that in 2011?
Provide a succinct answer. 0.99. What is the ratio of the Transition rate(%) in Gambia, The in 2006 to that in 2011?
Give a very brief answer. 1.05. What is the ratio of the Transition rate(%) in Fragile and conflict affected situations in 2007 to that in 2010?
Make the answer very short. 0.98. What is the ratio of the Transition rate(%) in Gambia, The in 2007 to that in 2010?
Provide a succinct answer. 0.98. What is the ratio of the Transition rate(%) in Malaysia in 2007 to that in 2010?
Your answer should be compact. 0.99. What is the ratio of the Transition rate(%) in Fragile and conflict affected situations in 2007 to that in 2011?
Offer a terse response. 0.99. What is the ratio of the Transition rate(%) of Gambia, The in 2007 to that in 2011?
Your answer should be very brief. 0.93. What is the ratio of the Transition rate(%) in Malaysia in 2007 to that in 2011?
Offer a terse response. 1. What is the ratio of the Transition rate(%) of Arab World in 2010 to that in 2011?
Your answer should be very brief. 1.01. What is the ratio of the Transition rate(%) of Fragile and conflict affected situations in 2010 to that in 2011?
Provide a short and direct response. 1.01. What is the ratio of the Transition rate(%) of Gambia, The in 2010 to that in 2011?
Make the answer very short. 0.95. What is the difference between the highest and the second highest Transition rate(%) in Arab World?
Make the answer very short. 0.95. What is the difference between the highest and the second highest Transition rate(%) in Fragile and conflict affected situations?
Your answer should be compact. 0.92. What is the difference between the highest and the second highest Transition rate(%) in Gambia, The?
Your answer should be very brief. 4.27. What is the difference between the highest and the second highest Transition rate(%) in Malaysia?
Provide a short and direct response. 0.63. What is the difference between the highest and the lowest Transition rate(%) in Arab World?
Offer a terse response. 4.44. What is the difference between the highest and the lowest Transition rate(%) in Fragile and conflict affected situations?
Your answer should be very brief. 8.69. What is the difference between the highest and the lowest Transition rate(%) of Gambia, The?
Your answer should be compact. 30.23. What is the difference between the highest and the lowest Transition rate(%) of Malaysia?
Provide a succinct answer. 1.98. 